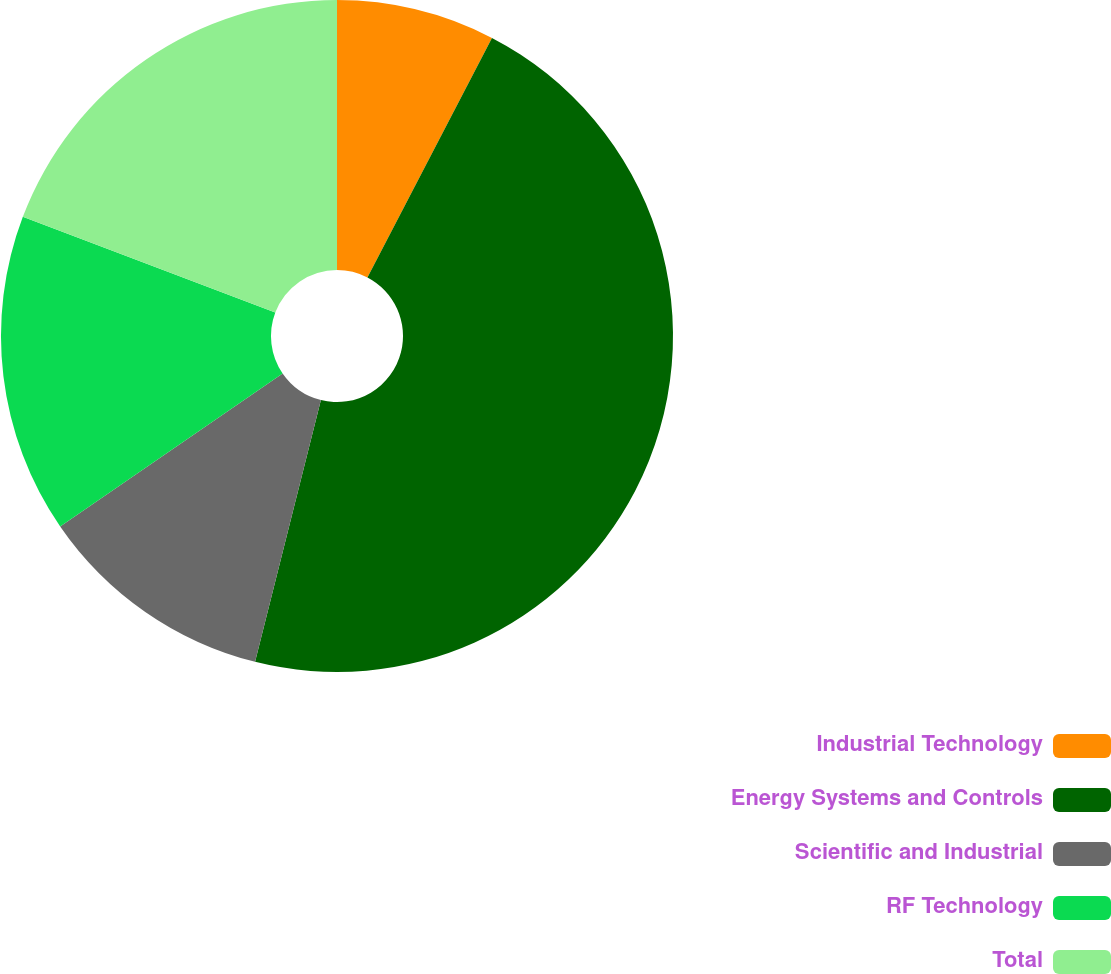Convert chart. <chart><loc_0><loc_0><loc_500><loc_500><pie_chart><fcel>Industrial Technology<fcel>Energy Systems and Controls<fcel>Scientific and Industrial<fcel>RF Technology<fcel>Total<nl><fcel>7.63%<fcel>46.29%<fcel>11.49%<fcel>15.36%<fcel>19.23%<nl></chart> 